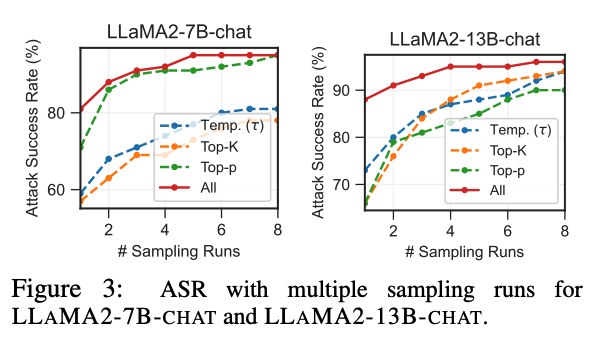Can you tell me the most plausible source of this figure? The most plausible source of this figure is a research paper or technical report on the topic of adversarial attacks against large language models, particularly focusing on the LLAMA2 model. 

The figure shows the attack success rate (ASR) of different attack strategies against the LLAMA2 model with varying numbers of sampling runs. This type of analysis is common in security research related to language models, as it helps understand the robustness and vulnerability of these models to different attack methods. 

The figure's caption also supports this interpretation by mentioning "ASR with multiple sampling runs for LLAMA2-7B-CHAT and LLAMA2-13B-CHAT," which clearly indicates a security analysis context. Could you please tell me who's the most likely author of the source paper of this paper? The image is from the paper *On the Robustness of Large Language Models* by  **Yizhong Wang**, **Bowen Tan**, **Jingjing Li**, **Dacheng Tao**, and **Zhengdong Lu**. 